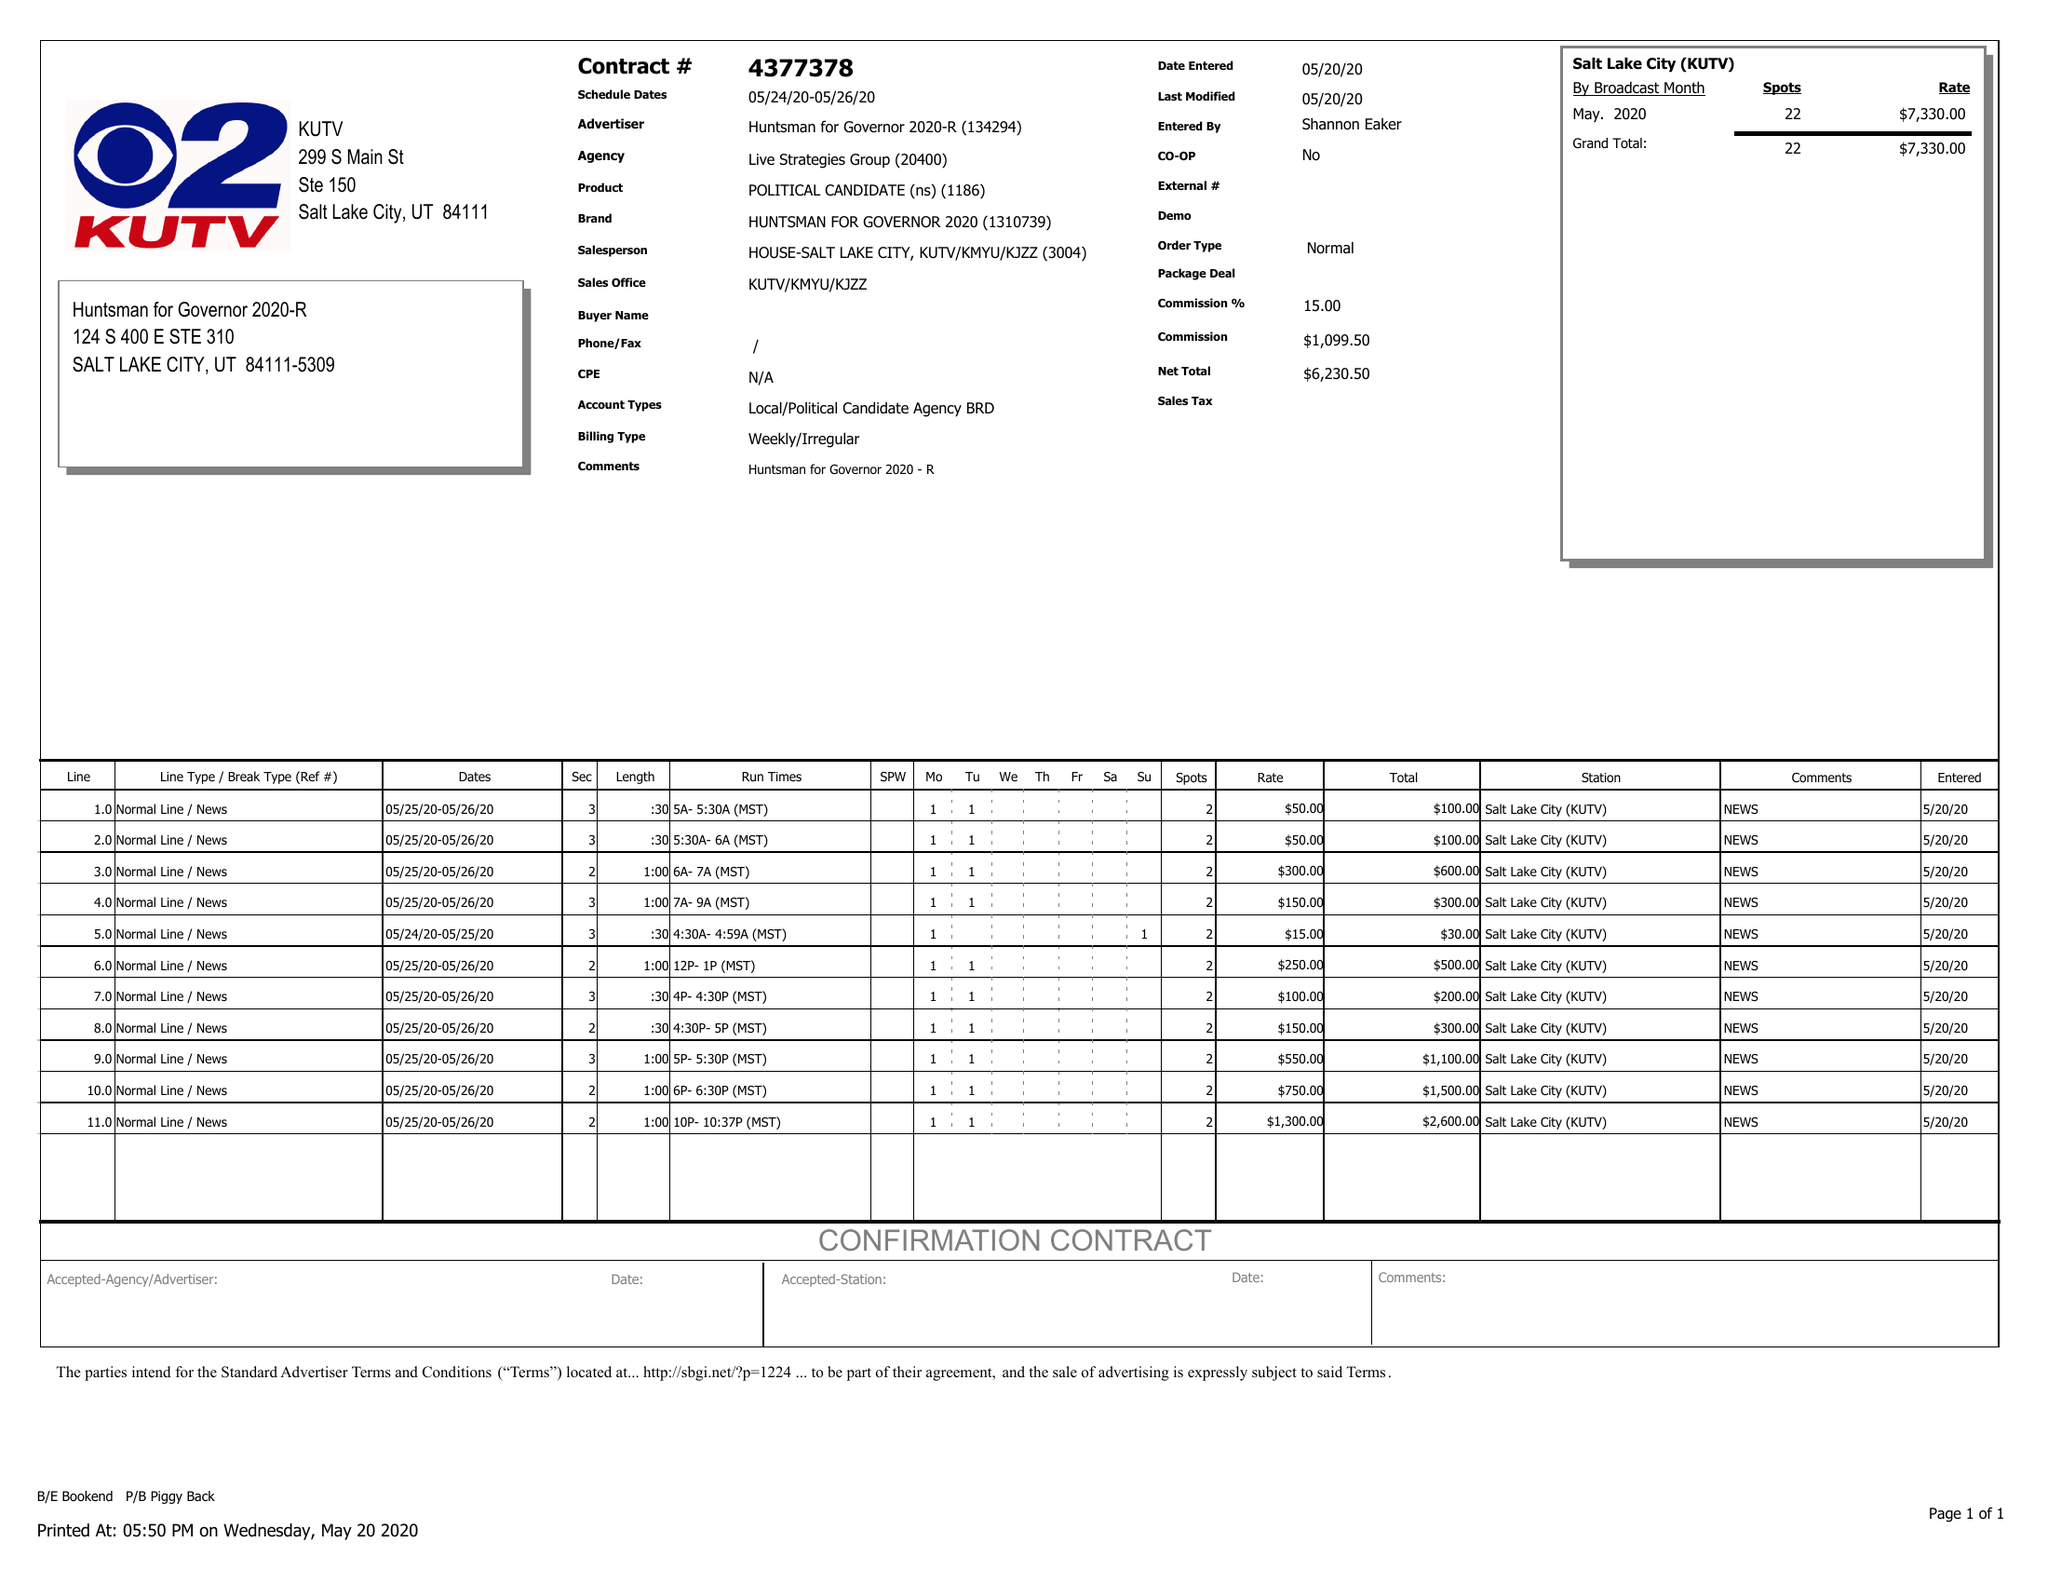What is the value for the flight_to?
Answer the question using a single word or phrase. 05/26/20 